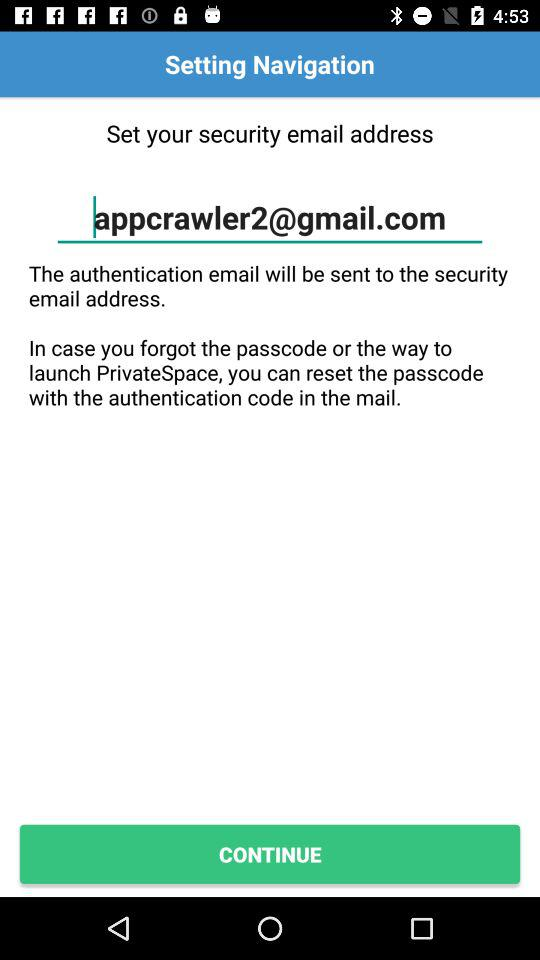How can the user reset the passcode? The user can reset the passcode with the authentication code in the mail. 